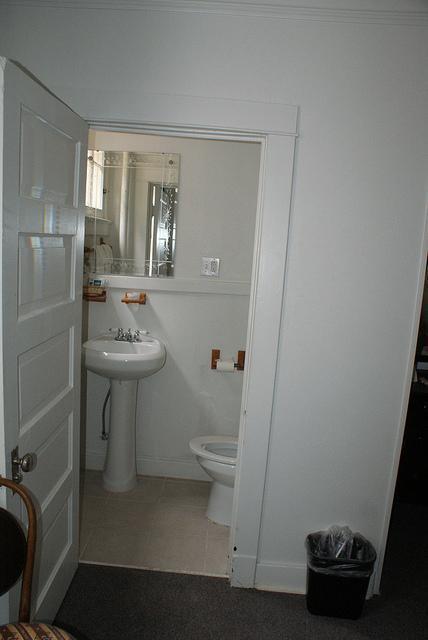How many doors are open?
Give a very brief answer. 1. How many urinals are shown?
Give a very brief answer. 0. How many pets are there?
Give a very brief answer. 0. How many mirrors are there?
Give a very brief answer. 1. How many rolls of toilet paper is there?
Give a very brief answer. 1. How many sinks are in the bathroom?
Give a very brief answer. 1. How many chairs are there?
Give a very brief answer. 1. How many buses are in view?
Give a very brief answer. 0. 